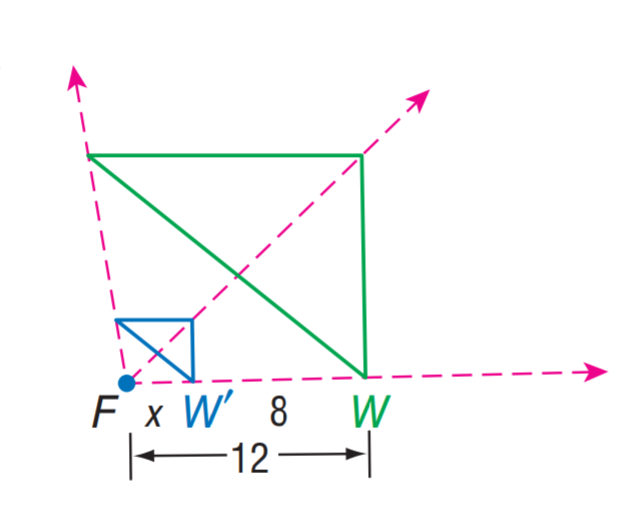Answer the mathemtical geometry problem and directly provide the correct option letter.
Question: Find x.
Choices: A: 4 B: 6 C: 8 D: 12 A 